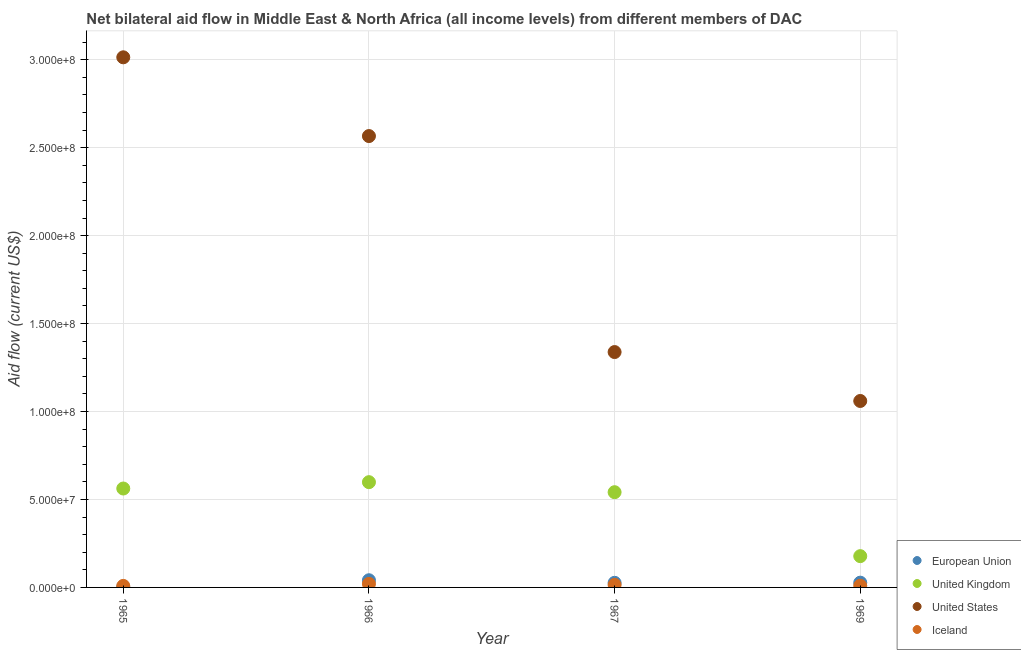Is the number of dotlines equal to the number of legend labels?
Keep it short and to the point. Yes. What is the amount of aid given by uk in 1965?
Make the answer very short. 5.62e+07. Across all years, what is the maximum amount of aid given by iceland?
Your response must be concise. 2.01e+06. Across all years, what is the minimum amount of aid given by iceland?
Your answer should be very brief. 8.70e+05. In which year was the amount of aid given by uk maximum?
Offer a terse response. 1966. In which year was the amount of aid given by uk minimum?
Offer a very short reply. 1969. What is the total amount of aid given by eu in the graph?
Offer a terse response. 9.63e+06. What is the difference between the amount of aid given by uk in 1965 and that in 1966?
Make the answer very short. -3.61e+06. What is the difference between the amount of aid given by iceland in 1965 and the amount of aid given by uk in 1967?
Offer a very short reply. -5.33e+07. What is the average amount of aid given by iceland per year?
Give a very brief answer. 1.32e+06. In the year 1969, what is the difference between the amount of aid given by uk and amount of aid given by us?
Offer a terse response. -8.82e+07. What is the ratio of the amount of aid given by us in 1967 to that in 1969?
Offer a very short reply. 1.26. Is the difference between the amount of aid given by uk in 1966 and 1967 greater than the difference between the amount of aid given by eu in 1966 and 1967?
Provide a succinct answer. Yes. What is the difference between the highest and the second highest amount of aid given by eu?
Your answer should be compact. 1.37e+06. What is the difference between the highest and the lowest amount of aid given by eu?
Give a very brief answer. 3.86e+06. In how many years, is the amount of aid given by eu greater than the average amount of aid given by eu taken over all years?
Offer a very short reply. 3. Is the sum of the amount of aid given by us in 1965 and 1969 greater than the maximum amount of aid given by iceland across all years?
Your answer should be very brief. Yes. Is it the case that in every year, the sum of the amount of aid given by us and amount of aid given by iceland is greater than the sum of amount of aid given by eu and amount of aid given by uk?
Ensure brevity in your answer.  Yes. Is it the case that in every year, the sum of the amount of aid given by eu and amount of aid given by uk is greater than the amount of aid given by us?
Keep it short and to the point. No. Does the amount of aid given by iceland monotonically increase over the years?
Provide a short and direct response. No. How many dotlines are there?
Offer a terse response. 4. What is the difference between two consecutive major ticks on the Y-axis?
Offer a terse response. 5.00e+07. Are the values on the major ticks of Y-axis written in scientific E-notation?
Offer a very short reply. Yes. How many legend labels are there?
Ensure brevity in your answer.  4. How are the legend labels stacked?
Keep it short and to the point. Vertical. What is the title of the graph?
Keep it short and to the point. Net bilateral aid flow in Middle East & North Africa (all income levels) from different members of DAC. What is the Aid flow (current US$) of United Kingdom in 1965?
Your answer should be compact. 5.62e+07. What is the Aid flow (current US$) in United States in 1965?
Give a very brief answer. 3.01e+08. What is the Aid flow (current US$) of Iceland in 1965?
Offer a very short reply. 8.70e+05. What is the Aid flow (current US$) in European Union in 1966?
Offer a terse response. 4.08e+06. What is the Aid flow (current US$) in United Kingdom in 1966?
Your answer should be very brief. 5.98e+07. What is the Aid flow (current US$) in United States in 1966?
Offer a terse response. 2.57e+08. What is the Aid flow (current US$) in Iceland in 1966?
Offer a very short reply. 2.01e+06. What is the Aid flow (current US$) in European Union in 1967?
Make the answer very short. 2.62e+06. What is the Aid flow (current US$) in United Kingdom in 1967?
Offer a terse response. 5.41e+07. What is the Aid flow (current US$) of United States in 1967?
Your response must be concise. 1.34e+08. What is the Aid flow (current US$) of Iceland in 1967?
Provide a succinct answer. 1.44e+06. What is the Aid flow (current US$) in European Union in 1969?
Provide a succinct answer. 2.71e+06. What is the Aid flow (current US$) of United Kingdom in 1969?
Make the answer very short. 1.78e+07. What is the Aid flow (current US$) of United States in 1969?
Your response must be concise. 1.06e+08. What is the Aid flow (current US$) in Iceland in 1969?
Offer a very short reply. 9.70e+05. Across all years, what is the maximum Aid flow (current US$) in European Union?
Offer a terse response. 4.08e+06. Across all years, what is the maximum Aid flow (current US$) in United Kingdom?
Your response must be concise. 5.98e+07. Across all years, what is the maximum Aid flow (current US$) of United States?
Your answer should be compact. 3.01e+08. Across all years, what is the maximum Aid flow (current US$) in Iceland?
Your answer should be very brief. 2.01e+06. Across all years, what is the minimum Aid flow (current US$) in European Union?
Keep it short and to the point. 2.20e+05. Across all years, what is the minimum Aid flow (current US$) of United Kingdom?
Give a very brief answer. 1.78e+07. Across all years, what is the minimum Aid flow (current US$) in United States?
Provide a short and direct response. 1.06e+08. Across all years, what is the minimum Aid flow (current US$) of Iceland?
Make the answer very short. 8.70e+05. What is the total Aid flow (current US$) in European Union in the graph?
Give a very brief answer. 9.63e+06. What is the total Aid flow (current US$) in United Kingdom in the graph?
Your answer should be compact. 1.88e+08. What is the total Aid flow (current US$) in United States in the graph?
Make the answer very short. 7.98e+08. What is the total Aid flow (current US$) of Iceland in the graph?
Give a very brief answer. 5.29e+06. What is the difference between the Aid flow (current US$) of European Union in 1965 and that in 1966?
Offer a very short reply. -3.86e+06. What is the difference between the Aid flow (current US$) of United Kingdom in 1965 and that in 1966?
Your response must be concise. -3.61e+06. What is the difference between the Aid flow (current US$) of United States in 1965 and that in 1966?
Provide a succinct answer. 4.48e+07. What is the difference between the Aid flow (current US$) in Iceland in 1965 and that in 1966?
Your response must be concise. -1.14e+06. What is the difference between the Aid flow (current US$) of European Union in 1965 and that in 1967?
Provide a succinct answer. -2.40e+06. What is the difference between the Aid flow (current US$) in United Kingdom in 1965 and that in 1967?
Offer a terse response. 2.09e+06. What is the difference between the Aid flow (current US$) of United States in 1965 and that in 1967?
Provide a short and direct response. 1.68e+08. What is the difference between the Aid flow (current US$) of Iceland in 1965 and that in 1967?
Your response must be concise. -5.70e+05. What is the difference between the Aid flow (current US$) in European Union in 1965 and that in 1969?
Keep it short and to the point. -2.49e+06. What is the difference between the Aid flow (current US$) in United Kingdom in 1965 and that in 1969?
Ensure brevity in your answer.  3.84e+07. What is the difference between the Aid flow (current US$) in United States in 1965 and that in 1969?
Make the answer very short. 1.95e+08. What is the difference between the Aid flow (current US$) in Iceland in 1965 and that in 1969?
Provide a short and direct response. -1.00e+05. What is the difference between the Aid flow (current US$) of European Union in 1966 and that in 1967?
Offer a terse response. 1.46e+06. What is the difference between the Aid flow (current US$) in United Kingdom in 1966 and that in 1967?
Your response must be concise. 5.70e+06. What is the difference between the Aid flow (current US$) of United States in 1966 and that in 1967?
Give a very brief answer. 1.23e+08. What is the difference between the Aid flow (current US$) of Iceland in 1966 and that in 1967?
Keep it short and to the point. 5.70e+05. What is the difference between the Aid flow (current US$) of European Union in 1966 and that in 1969?
Your response must be concise. 1.37e+06. What is the difference between the Aid flow (current US$) of United Kingdom in 1966 and that in 1969?
Offer a very short reply. 4.21e+07. What is the difference between the Aid flow (current US$) in United States in 1966 and that in 1969?
Make the answer very short. 1.51e+08. What is the difference between the Aid flow (current US$) of Iceland in 1966 and that in 1969?
Offer a terse response. 1.04e+06. What is the difference between the Aid flow (current US$) in United Kingdom in 1967 and that in 1969?
Your answer should be compact. 3.64e+07. What is the difference between the Aid flow (current US$) of United States in 1967 and that in 1969?
Offer a terse response. 2.78e+07. What is the difference between the Aid flow (current US$) of Iceland in 1967 and that in 1969?
Your response must be concise. 4.70e+05. What is the difference between the Aid flow (current US$) of European Union in 1965 and the Aid flow (current US$) of United Kingdom in 1966?
Offer a terse response. -5.96e+07. What is the difference between the Aid flow (current US$) in European Union in 1965 and the Aid flow (current US$) in United States in 1966?
Provide a short and direct response. -2.56e+08. What is the difference between the Aid flow (current US$) of European Union in 1965 and the Aid flow (current US$) of Iceland in 1966?
Your answer should be compact. -1.79e+06. What is the difference between the Aid flow (current US$) of United Kingdom in 1965 and the Aid flow (current US$) of United States in 1966?
Keep it short and to the point. -2.00e+08. What is the difference between the Aid flow (current US$) of United Kingdom in 1965 and the Aid flow (current US$) of Iceland in 1966?
Ensure brevity in your answer.  5.42e+07. What is the difference between the Aid flow (current US$) in United States in 1965 and the Aid flow (current US$) in Iceland in 1966?
Give a very brief answer. 2.99e+08. What is the difference between the Aid flow (current US$) in European Union in 1965 and the Aid flow (current US$) in United Kingdom in 1967?
Your answer should be very brief. -5.39e+07. What is the difference between the Aid flow (current US$) in European Union in 1965 and the Aid flow (current US$) in United States in 1967?
Your answer should be compact. -1.34e+08. What is the difference between the Aid flow (current US$) in European Union in 1965 and the Aid flow (current US$) in Iceland in 1967?
Your response must be concise. -1.22e+06. What is the difference between the Aid flow (current US$) of United Kingdom in 1965 and the Aid flow (current US$) of United States in 1967?
Your response must be concise. -7.76e+07. What is the difference between the Aid flow (current US$) of United Kingdom in 1965 and the Aid flow (current US$) of Iceland in 1967?
Give a very brief answer. 5.48e+07. What is the difference between the Aid flow (current US$) in United States in 1965 and the Aid flow (current US$) in Iceland in 1967?
Offer a very short reply. 3.00e+08. What is the difference between the Aid flow (current US$) in European Union in 1965 and the Aid flow (current US$) in United Kingdom in 1969?
Offer a terse response. -1.76e+07. What is the difference between the Aid flow (current US$) in European Union in 1965 and the Aid flow (current US$) in United States in 1969?
Your response must be concise. -1.06e+08. What is the difference between the Aid flow (current US$) of European Union in 1965 and the Aid flow (current US$) of Iceland in 1969?
Provide a succinct answer. -7.50e+05. What is the difference between the Aid flow (current US$) of United Kingdom in 1965 and the Aid flow (current US$) of United States in 1969?
Ensure brevity in your answer.  -4.98e+07. What is the difference between the Aid flow (current US$) of United Kingdom in 1965 and the Aid flow (current US$) of Iceland in 1969?
Give a very brief answer. 5.53e+07. What is the difference between the Aid flow (current US$) of United States in 1965 and the Aid flow (current US$) of Iceland in 1969?
Keep it short and to the point. 3.00e+08. What is the difference between the Aid flow (current US$) in European Union in 1966 and the Aid flow (current US$) in United Kingdom in 1967?
Offer a terse response. -5.01e+07. What is the difference between the Aid flow (current US$) of European Union in 1966 and the Aid flow (current US$) of United States in 1967?
Keep it short and to the point. -1.30e+08. What is the difference between the Aid flow (current US$) of European Union in 1966 and the Aid flow (current US$) of Iceland in 1967?
Offer a terse response. 2.64e+06. What is the difference between the Aid flow (current US$) in United Kingdom in 1966 and the Aid flow (current US$) in United States in 1967?
Offer a very short reply. -7.40e+07. What is the difference between the Aid flow (current US$) in United Kingdom in 1966 and the Aid flow (current US$) in Iceland in 1967?
Ensure brevity in your answer.  5.84e+07. What is the difference between the Aid flow (current US$) of United States in 1966 and the Aid flow (current US$) of Iceland in 1967?
Ensure brevity in your answer.  2.55e+08. What is the difference between the Aid flow (current US$) of European Union in 1966 and the Aid flow (current US$) of United Kingdom in 1969?
Give a very brief answer. -1.37e+07. What is the difference between the Aid flow (current US$) in European Union in 1966 and the Aid flow (current US$) in United States in 1969?
Your response must be concise. -1.02e+08. What is the difference between the Aid flow (current US$) of European Union in 1966 and the Aid flow (current US$) of Iceland in 1969?
Give a very brief answer. 3.11e+06. What is the difference between the Aid flow (current US$) of United Kingdom in 1966 and the Aid flow (current US$) of United States in 1969?
Ensure brevity in your answer.  -4.62e+07. What is the difference between the Aid flow (current US$) of United Kingdom in 1966 and the Aid flow (current US$) of Iceland in 1969?
Provide a succinct answer. 5.89e+07. What is the difference between the Aid flow (current US$) of United States in 1966 and the Aid flow (current US$) of Iceland in 1969?
Keep it short and to the point. 2.56e+08. What is the difference between the Aid flow (current US$) of European Union in 1967 and the Aid flow (current US$) of United Kingdom in 1969?
Provide a short and direct response. -1.52e+07. What is the difference between the Aid flow (current US$) in European Union in 1967 and the Aid flow (current US$) in United States in 1969?
Your response must be concise. -1.03e+08. What is the difference between the Aid flow (current US$) in European Union in 1967 and the Aid flow (current US$) in Iceland in 1969?
Offer a terse response. 1.65e+06. What is the difference between the Aid flow (current US$) of United Kingdom in 1967 and the Aid flow (current US$) of United States in 1969?
Provide a succinct answer. -5.19e+07. What is the difference between the Aid flow (current US$) in United Kingdom in 1967 and the Aid flow (current US$) in Iceland in 1969?
Your answer should be very brief. 5.32e+07. What is the difference between the Aid flow (current US$) of United States in 1967 and the Aid flow (current US$) of Iceland in 1969?
Provide a succinct answer. 1.33e+08. What is the average Aid flow (current US$) in European Union per year?
Ensure brevity in your answer.  2.41e+06. What is the average Aid flow (current US$) of United Kingdom per year?
Your answer should be compact. 4.70e+07. What is the average Aid flow (current US$) in United States per year?
Your answer should be very brief. 1.99e+08. What is the average Aid flow (current US$) of Iceland per year?
Offer a very short reply. 1.32e+06. In the year 1965, what is the difference between the Aid flow (current US$) in European Union and Aid flow (current US$) in United Kingdom?
Ensure brevity in your answer.  -5.60e+07. In the year 1965, what is the difference between the Aid flow (current US$) of European Union and Aid flow (current US$) of United States?
Your answer should be compact. -3.01e+08. In the year 1965, what is the difference between the Aid flow (current US$) in European Union and Aid flow (current US$) in Iceland?
Your answer should be very brief. -6.50e+05. In the year 1965, what is the difference between the Aid flow (current US$) in United Kingdom and Aid flow (current US$) in United States?
Offer a very short reply. -2.45e+08. In the year 1965, what is the difference between the Aid flow (current US$) in United Kingdom and Aid flow (current US$) in Iceland?
Ensure brevity in your answer.  5.54e+07. In the year 1965, what is the difference between the Aid flow (current US$) of United States and Aid flow (current US$) of Iceland?
Your response must be concise. 3.00e+08. In the year 1966, what is the difference between the Aid flow (current US$) of European Union and Aid flow (current US$) of United Kingdom?
Your answer should be very brief. -5.58e+07. In the year 1966, what is the difference between the Aid flow (current US$) in European Union and Aid flow (current US$) in United States?
Give a very brief answer. -2.53e+08. In the year 1966, what is the difference between the Aid flow (current US$) of European Union and Aid flow (current US$) of Iceland?
Give a very brief answer. 2.07e+06. In the year 1966, what is the difference between the Aid flow (current US$) in United Kingdom and Aid flow (current US$) in United States?
Give a very brief answer. -1.97e+08. In the year 1966, what is the difference between the Aid flow (current US$) of United Kingdom and Aid flow (current US$) of Iceland?
Ensure brevity in your answer.  5.78e+07. In the year 1966, what is the difference between the Aid flow (current US$) in United States and Aid flow (current US$) in Iceland?
Keep it short and to the point. 2.55e+08. In the year 1967, what is the difference between the Aid flow (current US$) of European Union and Aid flow (current US$) of United Kingdom?
Make the answer very short. -5.15e+07. In the year 1967, what is the difference between the Aid flow (current US$) in European Union and Aid flow (current US$) in United States?
Your answer should be very brief. -1.31e+08. In the year 1967, what is the difference between the Aid flow (current US$) of European Union and Aid flow (current US$) of Iceland?
Offer a terse response. 1.18e+06. In the year 1967, what is the difference between the Aid flow (current US$) in United Kingdom and Aid flow (current US$) in United States?
Your response must be concise. -7.97e+07. In the year 1967, what is the difference between the Aid flow (current US$) of United Kingdom and Aid flow (current US$) of Iceland?
Keep it short and to the point. 5.27e+07. In the year 1967, what is the difference between the Aid flow (current US$) in United States and Aid flow (current US$) in Iceland?
Provide a short and direct response. 1.32e+08. In the year 1969, what is the difference between the Aid flow (current US$) in European Union and Aid flow (current US$) in United Kingdom?
Your response must be concise. -1.51e+07. In the year 1969, what is the difference between the Aid flow (current US$) of European Union and Aid flow (current US$) of United States?
Keep it short and to the point. -1.03e+08. In the year 1969, what is the difference between the Aid flow (current US$) of European Union and Aid flow (current US$) of Iceland?
Make the answer very short. 1.74e+06. In the year 1969, what is the difference between the Aid flow (current US$) of United Kingdom and Aid flow (current US$) of United States?
Give a very brief answer. -8.82e+07. In the year 1969, what is the difference between the Aid flow (current US$) of United Kingdom and Aid flow (current US$) of Iceland?
Keep it short and to the point. 1.68e+07. In the year 1969, what is the difference between the Aid flow (current US$) of United States and Aid flow (current US$) of Iceland?
Keep it short and to the point. 1.05e+08. What is the ratio of the Aid flow (current US$) of European Union in 1965 to that in 1966?
Provide a succinct answer. 0.05. What is the ratio of the Aid flow (current US$) in United Kingdom in 1965 to that in 1966?
Keep it short and to the point. 0.94. What is the ratio of the Aid flow (current US$) in United States in 1965 to that in 1966?
Make the answer very short. 1.17. What is the ratio of the Aid flow (current US$) in Iceland in 1965 to that in 1966?
Make the answer very short. 0.43. What is the ratio of the Aid flow (current US$) in European Union in 1965 to that in 1967?
Offer a very short reply. 0.08. What is the ratio of the Aid flow (current US$) of United Kingdom in 1965 to that in 1967?
Give a very brief answer. 1.04. What is the ratio of the Aid flow (current US$) of United States in 1965 to that in 1967?
Your response must be concise. 2.25. What is the ratio of the Aid flow (current US$) in Iceland in 1965 to that in 1967?
Make the answer very short. 0.6. What is the ratio of the Aid flow (current US$) in European Union in 1965 to that in 1969?
Offer a very short reply. 0.08. What is the ratio of the Aid flow (current US$) in United Kingdom in 1965 to that in 1969?
Provide a succinct answer. 3.16. What is the ratio of the Aid flow (current US$) in United States in 1965 to that in 1969?
Your response must be concise. 2.84. What is the ratio of the Aid flow (current US$) of Iceland in 1965 to that in 1969?
Give a very brief answer. 0.9. What is the ratio of the Aid flow (current US$) of European Union in 1966 to that in 1967?
Offer a very short reply. 1.56. What is the ratio of the Aid flow (current US$) in United Kingdom in 1966 to that in 1967?
Keep it short and to the point. 1.11. What is the ratio of the Aid flow (current US$) of United States in 1966 to that in 1967?
Make the answer very short. 1.92. What is the ratio of the Aid flow (current US$) of Iceland in 1966 to that in 1967?
Provide a succinct answer. 1.4. What is the ratio of the Aid flow (current US$) of European Union in 1966 to that in 1969?
Ensure brevity in your answer.  1.51. What is the ratio of the Aid flow (current US$) of United Kingdom in 1966 to that in 1969?
Provide a succinct answer. 3.37. What is the ratio of the Aid flow (current US$) in United States in 1966 to that in 1969?
Your answer should be compact. 2.42. What is the ratio of the Aid flow (current US$) in Iceland in 1966 to that in 1969?
Your answer should be compact. 2.07. What is the ratio of the Aid flow (current US$) in European Union in 1967 to that in 1969?
Your answer should be very brief. 0.97. What is the ratio of the Aid flow (current US$) in United Kingdom in 1967 to that in 1969?
Ensure brevity in your answer.  3.04. What is the ratio of the Aid flow (current US$) of United States in 1967 to that in 1969?
Provide a short and direct response. 1.26. What is the ratio of the Aid flow (current US$) of Iceland in 1967 to that in 1969?
Your answer should be compact. 1.48. What is the difference between the highest and the second highest Aid flow (current US$) of European Union?
Offer a very short reply. 1.37e+06. What is the difference between the highest and the second highest Aid flow (current US$) in United Kingdom?
Ensure brevity in your answer.  3.61e+06. What is the difference between the highest and the second highest Aid flow (current US$) of United States?
Your answer should be very brief. 4.48e+07. What is the difference between the highest and the second highest Aid flow (current US$) of Iceland?
Keep it short and to the point. 5.70e+05. What is the difference between the highest and the lowest Aid flow (current US$) in European Union?
Offer a terse response. 3.86e+06. What is the difference between the highest and the lowest Aid flow (current US$) in United Kingdom?
Ensure brevity in your answer.  4.21e+07. What is the difference between the highest and the lowest Aid flow (current US$) in United States?
Ensure brevity in your answer.  1.95e+08. What is the difference between the highest and the lowest Aid flow (current US$) in Iceland?
Your answer should be compact. 1.14e+06. 